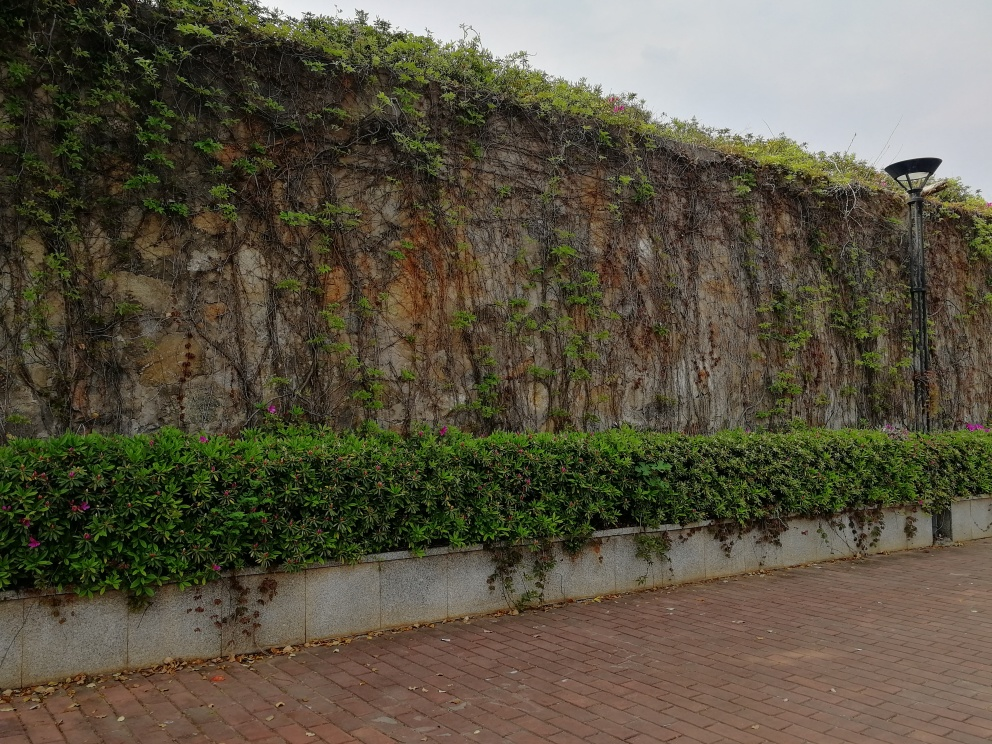Are texture details of the green plants in the subject area lost? The texture details of the green plants are somewhat visible, but certain areas are less distinct, potentially due to the image's lighting and resolution. You can observe the varied shades of green and some leaf patterns, though finer textures might not be as clear. 